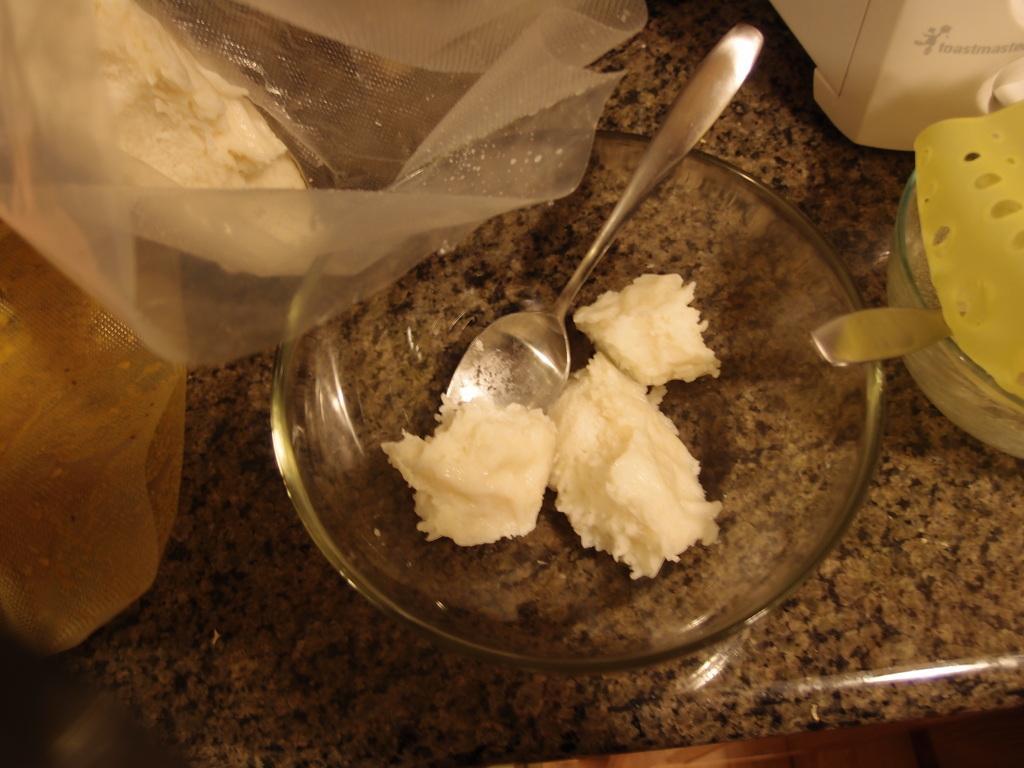Could you give a brief overview of what you see in this image? In the image there is a bowl with a spoon and cream in it. On the right side of the image there is a bowl with a spoon and an object in it. On the left side of the image there are covers. In the top right corner of the image there is an object with text on it.  